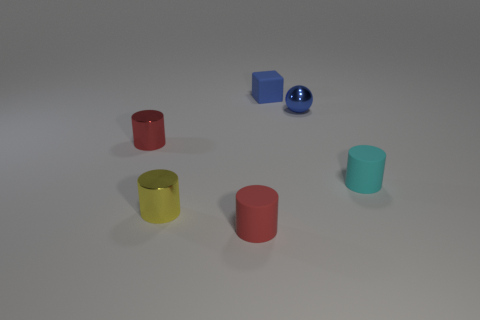Subtract all gray cylinders. Subtract all red balls. How many cylinders are left? 4 Add 4 small red metallic cylinders. How many objects exist? 10 Subtract all cylinders. How many objects are left? 2 Add 4 small blue rubber blocks. How many small blue rubber blocks are left? 5 Add 4 large red metallic objects. How many large red metallic objects exist? 4 Subtract 0 red spheres. How many objects are left? 6 Subtract all small cyan metal balls. Subtract all yellow shiny objects. How many objects are left? 5 